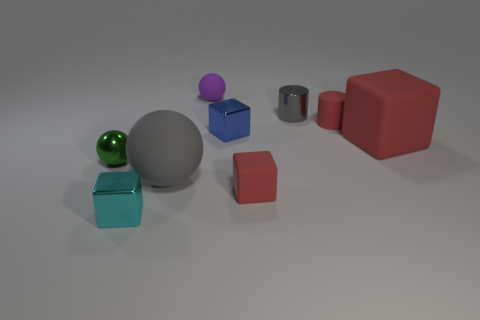Add 1 big gray things. How many objects exist? 10 Subtract all balls. How many objects are left? 6 Add 5 green metal things. How many green metal things are left? 6 Add 8 big rubber balls. How many big rubber balls exist? 9 Subtract 0 cyan cylinders. How many objects are left? 9 Subtract all red metal cylinders. Subtract all large matte blocks. How many objects are left? 8 